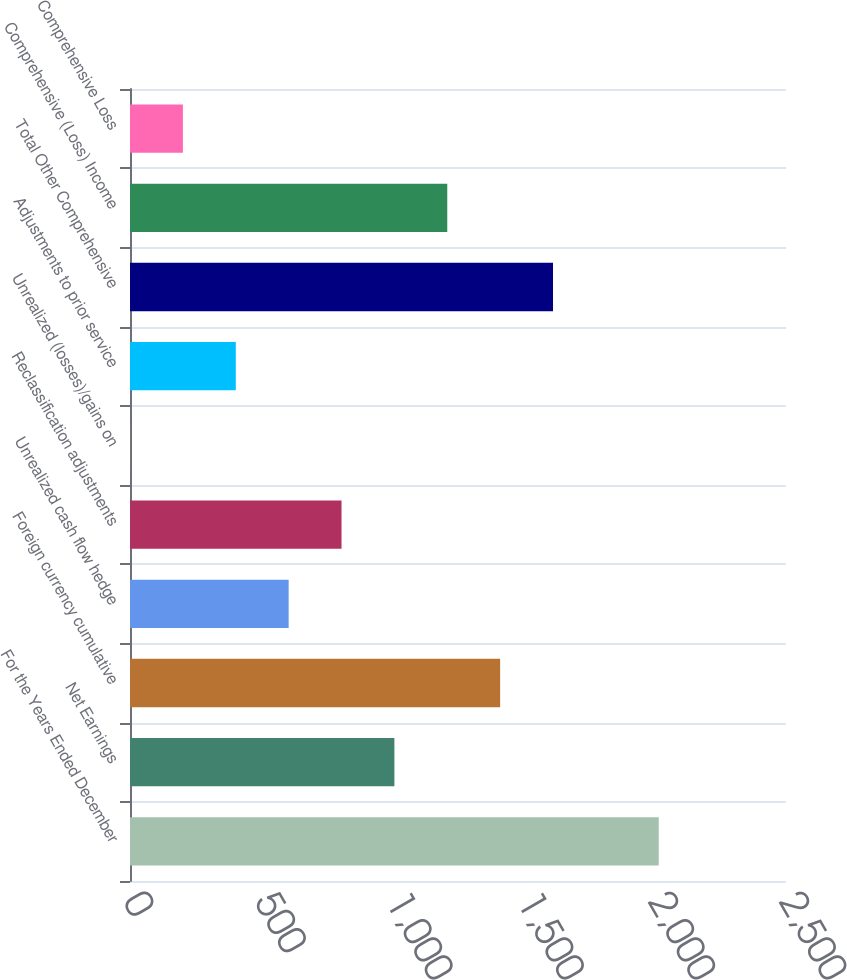<chart> <loc_0><loc_0><loc_500><loc_500><bar_chart><fcel>For the Years Ended December<fcel>Net Earnings<fcel>Foreign currency cumulative<fcel>Unrealized cash flow hedge<fcel>Reclassification adjustments<fcel>Unrealized (losses)/gains on<fcel>Adjustments to prior service<fcel>Total Other Comprehensive<fcel>Comprehensive (Loss) Income<fcel>Comprehensive Loss<nl><fcel>2015<fcel>1007.6<fcel>1410.56<fcel>604.64<fcel>806.12<fcel>0.2<fcel>403.16<fcel>1612.04<fcel>1209.08<fcel>201.68<nl></chart> 